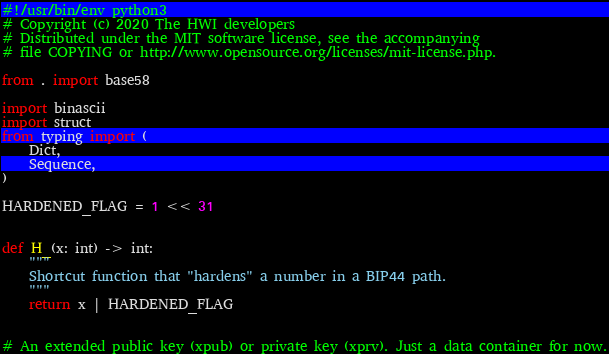<code> <loc_0><loc_0><loc_500><loc_500><_Python_>#!/usr/bin/env python3
# Copyright (c) 2020 The HWI developers
# Distributed under the MIT software license, see the accompanying
# file COPYING or http://www.opensource.org/licenses/mit-license.php.

from . import base58

import binascii
import struct
from typing import (
    Dict,
    Sequence,
)

HARDENED_FLAG = 1 << 31


def H_(x: int) -> int:
    """
    Shortcut function that "hardens" a number in a BIP44 path.
    """
    return x | HARDENED_FLAG


# An extended public key (xpub) or private key (xprv). Just a data container for now.</code> 